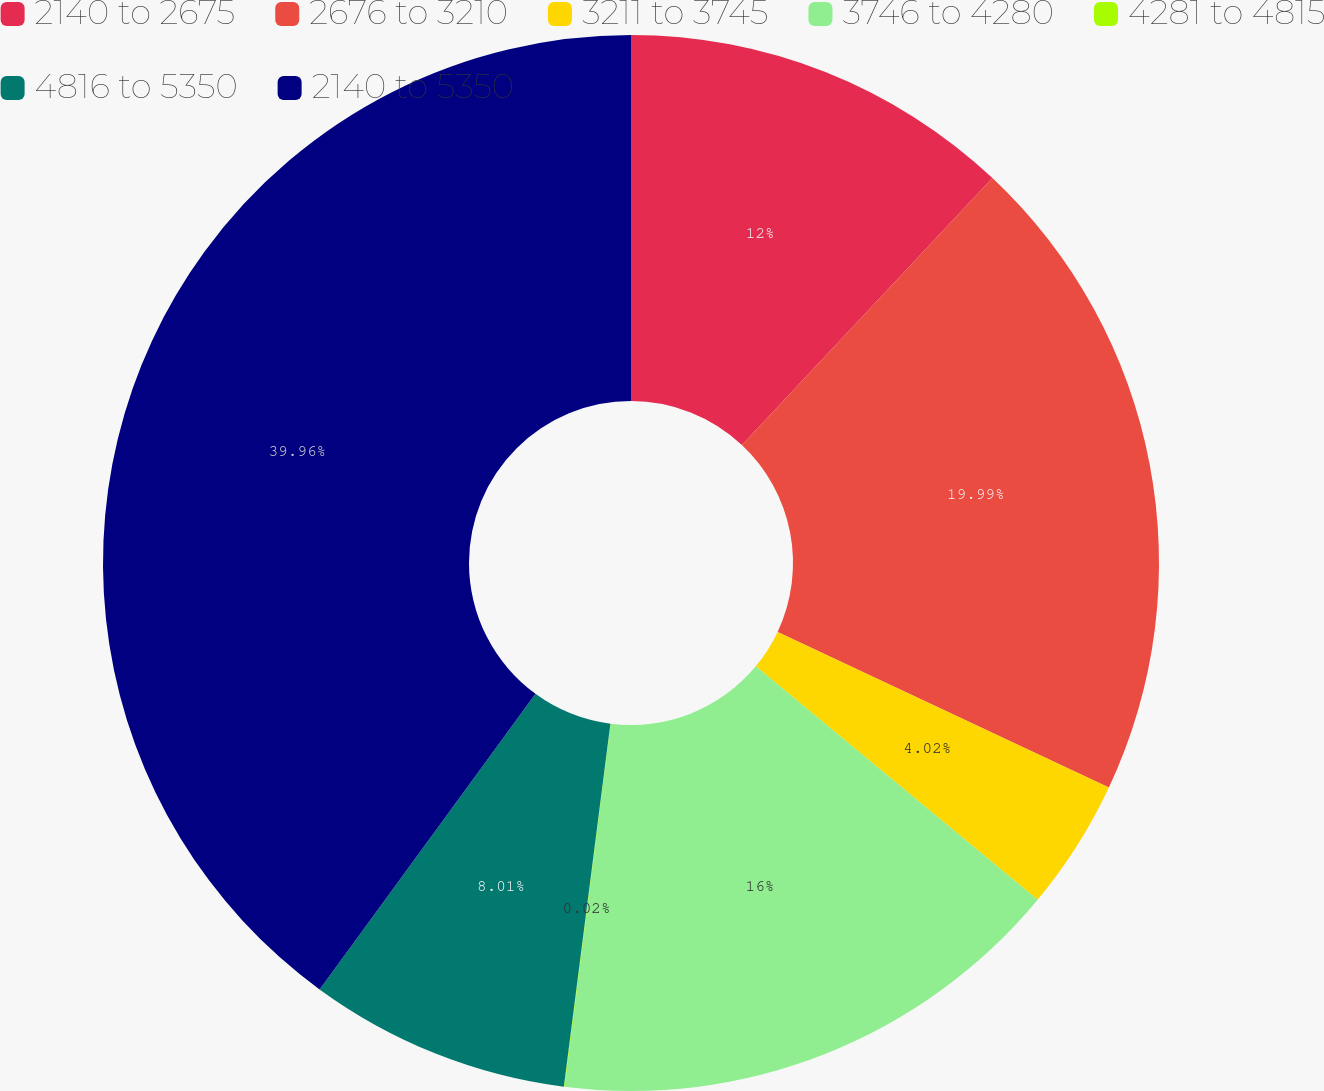Convert chart to OTSL. <chart><loc_0><loc_0><loc_500><loc_500><pie_chart><fcel>2140 to 2675<fcel>2676 to 3210<fcel>3211 to 3745<fcel>3746 to 4280<fcel>4281 to 4815<fcel>4816 to 5350<fcel>2140 to 5350<nl><fcel>12.0%<fcel>19.99%<fcel>4.02%<fcel>16.0%<fcel>0.02%<fcel>8.01%<fcel>39.96%<nl></chart> 